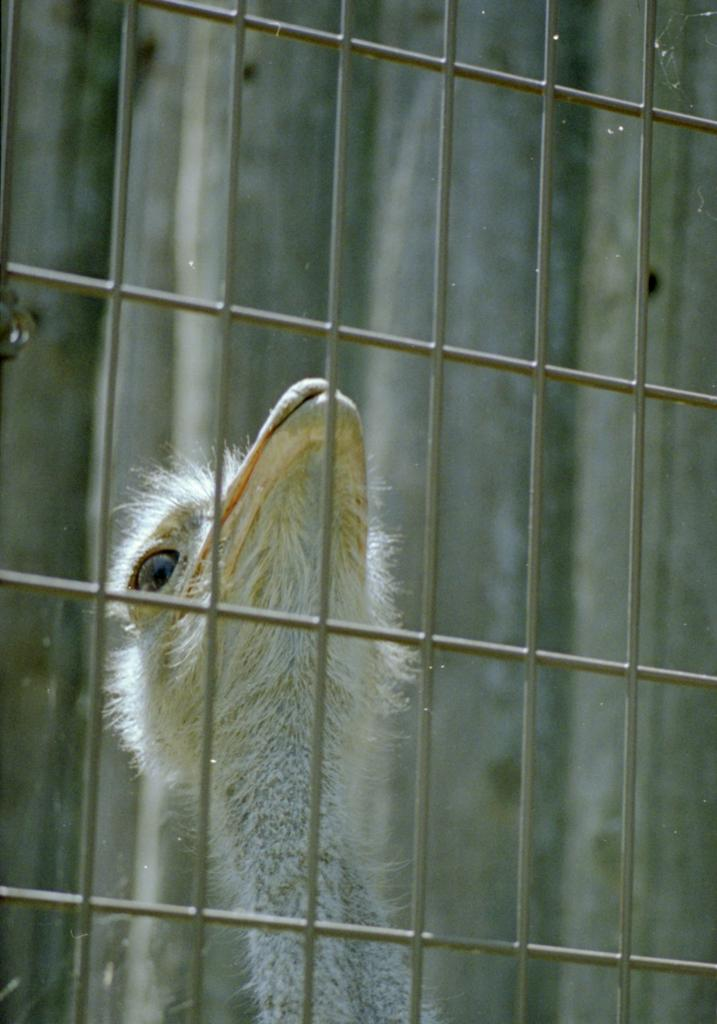What type of structure can be seen in the image? There is a railing in the image. What type of animal is visible in the image? A bird's head with a neck is visible in the image. What color is the bird's eye? The bird's eye is white in color. What color is the bird's beak? The bird's beak is white in color. What type of sponge can be seen cleaning the bird's beak in the image? There is no sponge present in the image, and the bird's beak is not being cleaned. What creature is responsible for the way the bird's head is positioned in the image? The bird's head position is determined by the bird itself and not by any other creature. 